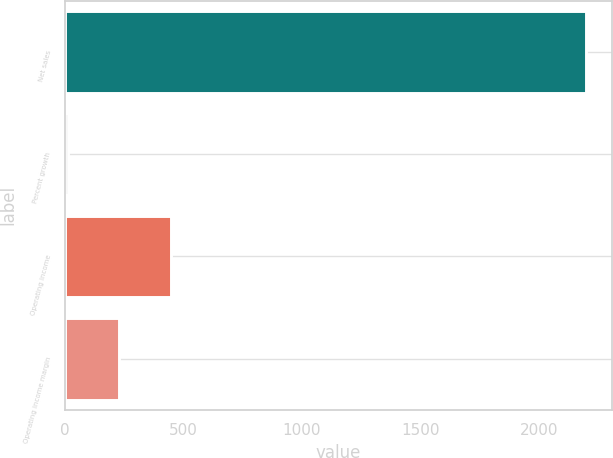<chart> <loc_0><loc_0><loc_500><loc_500><bar_chart><fcel>Net sales<fcel>Percent growth<fcel>Operating income<fcel>Operating income margin<nl><fcel>2199.9<fcel>10<fcel>447.98<fcel>228.99<nl></chart> 